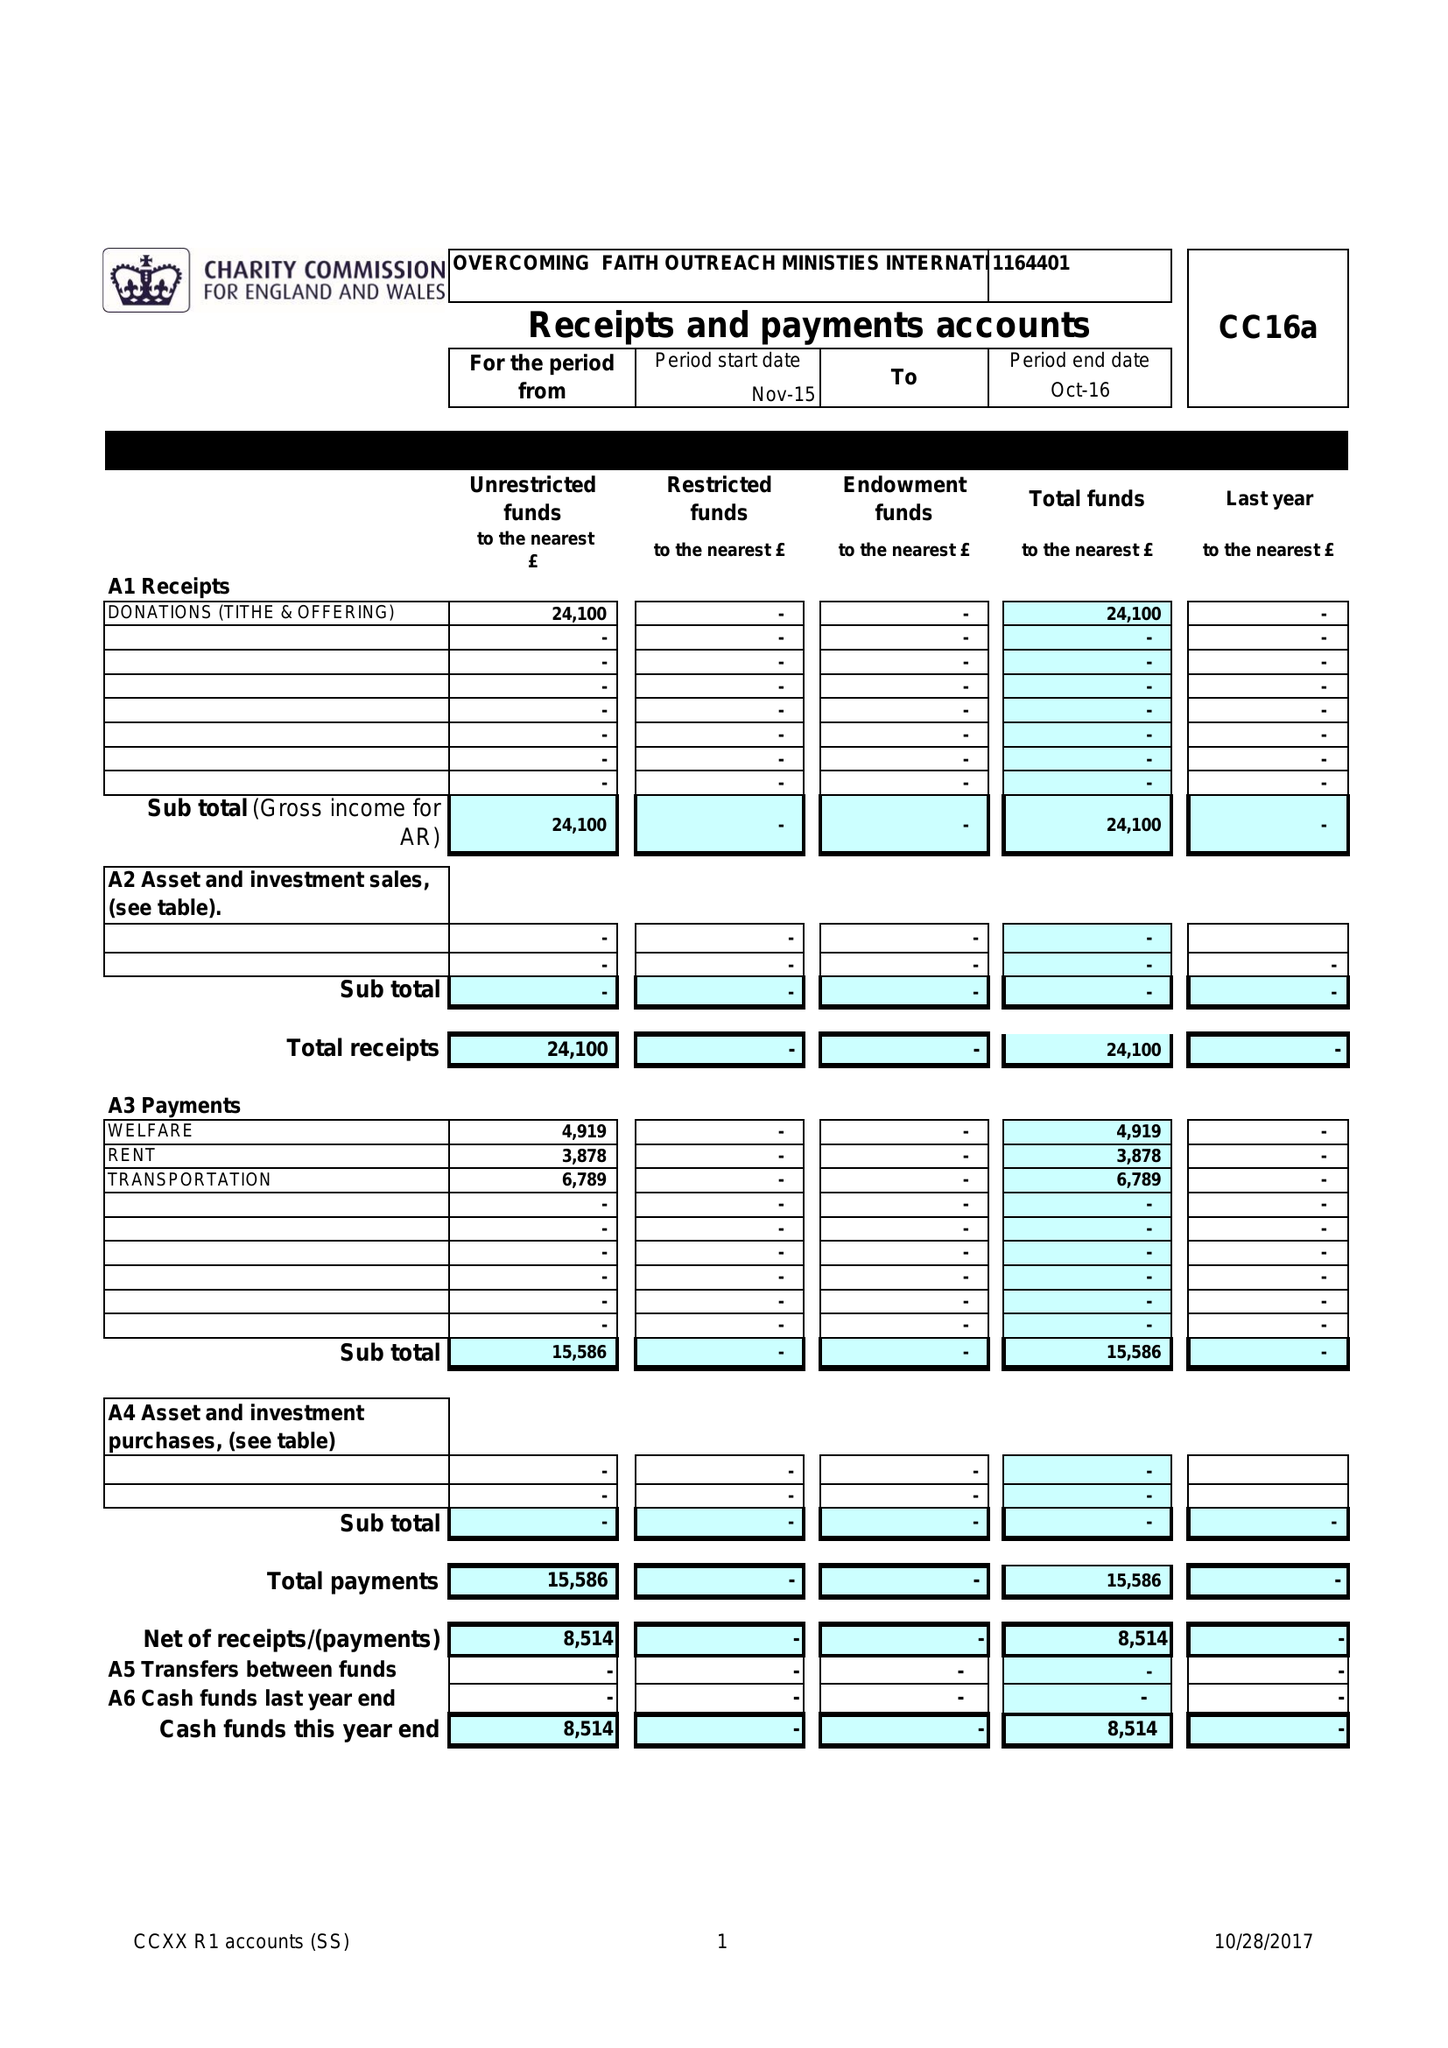What is the value for the address__postcode?
Answer the question using a single word or phrase. RM3 8YD 